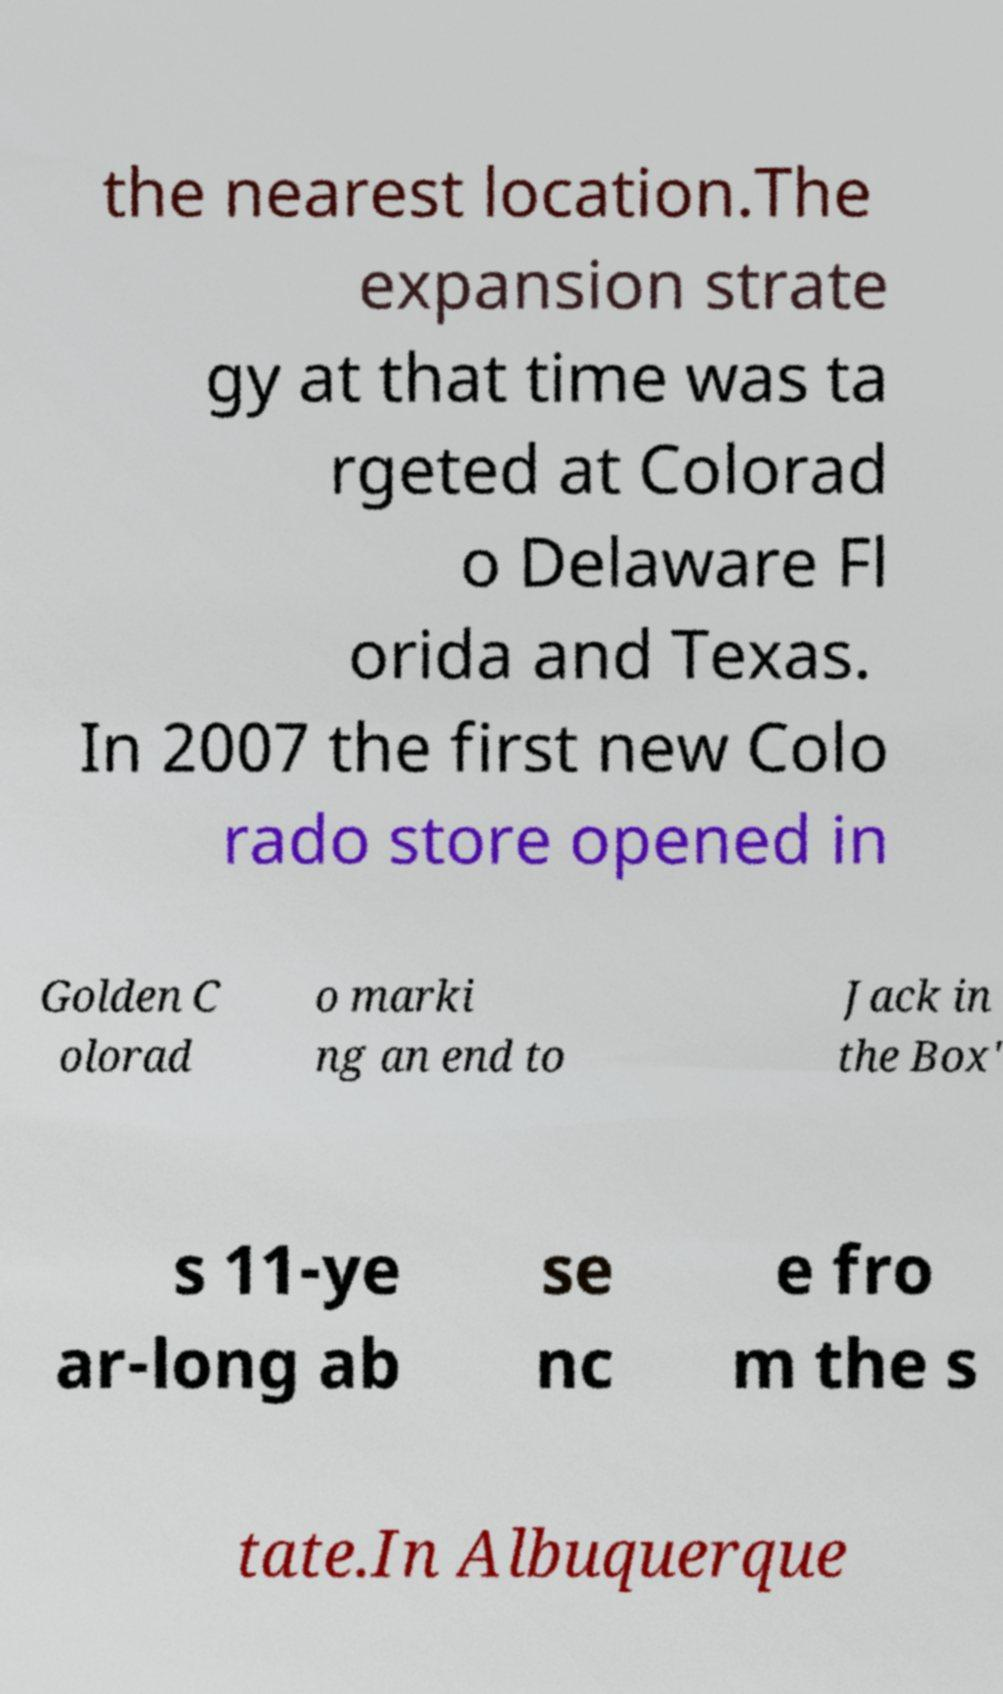Please identify and transcribe the text found in this image. the nearest location.The expansion strate gy at that time was ta rgeted at Colorad o Delaware Fl orida and Texas. In 2007 the first new Colo rado store opened in Golden C olorad o marki ng an end to Jack in the Box' s 11-ye ar-long ab se nc e fro m the s tate.In Albuquerque 